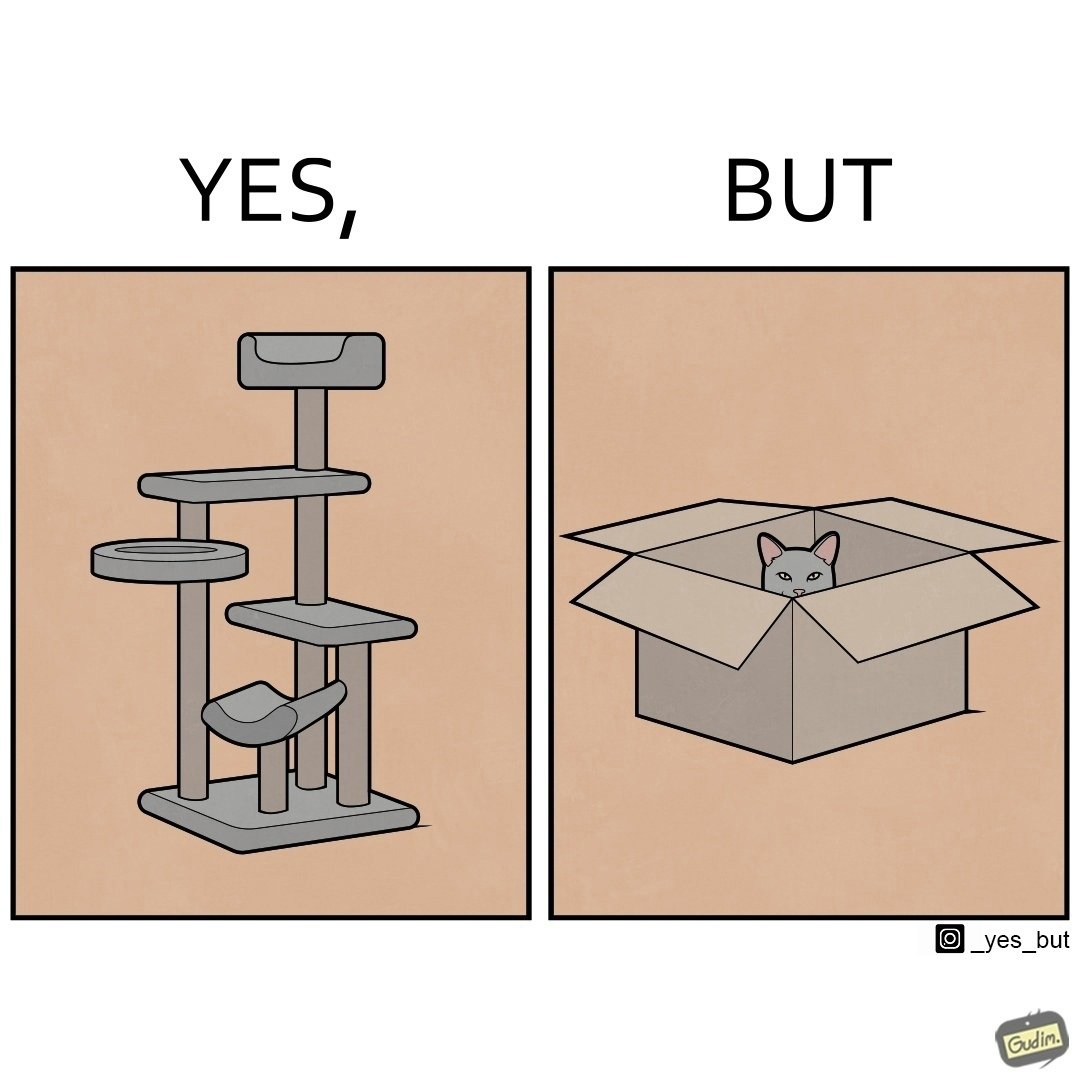What is the satirical meaning behind this image? The images are funny since even though a cat tree is bought for cats to play with, cats would usually rather play with inexpensive cardboard boxes because they enjoy it more 